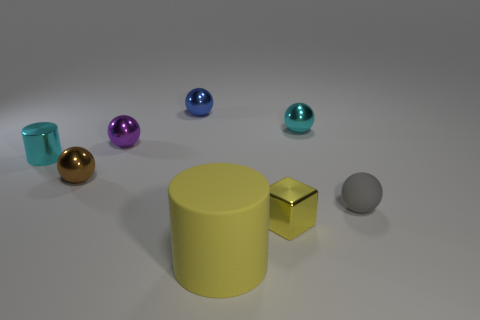There is a thing that is both behind the rubber cylinder and in front of the gray rubber sphere; what is its size?
Your response must be concise. Small. Is the number of tiny cyan metallic balls to the left of the tiny purple metallic thing less than the number of gray things?
Your answer should be very brief. Yes. The brown thing that is the same material as the small blue object is what shape?
Keep it short and to the point. Sphere. Does the tiny cyan thing to the right of the small metallic block have the same shape as the cyan shiny object to the left of the blue shiny ball?
Your response must be concise. No. Is the number of gray matte objects behind the brown object less than the number of yellow matte things in front of the cyan metal ball?
Offer a terse response. Yes. What is the shape of the other thing that is the same color as the big object?
Offer a very short reply. Cube. How many brown metal balls are the same size as the purple sphere?
Make the answer very short. 1. Do the cylinder that is to the left of the small blue metallic object and the brown ball have the same material?
Your response must be concise. Yes. Is there a metal cube?
Offer a terse response. Yes. What is the size of the blue object that is the same material as the tiny cyan ball?
Offer a very short reply. Small. 